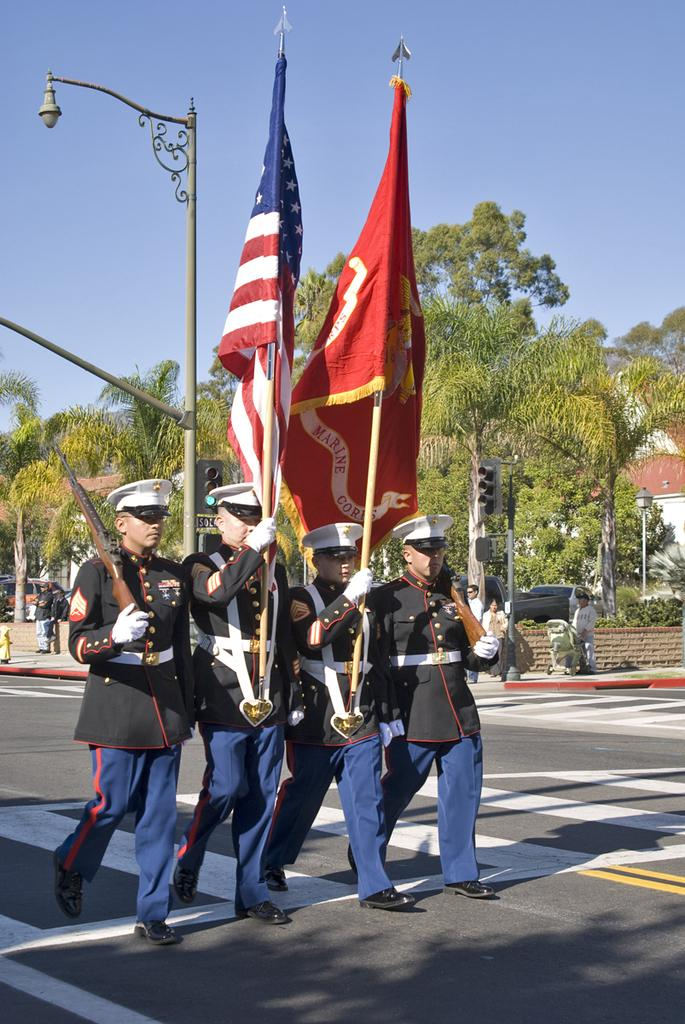How many people are in the image? There is a group of persons in the image. What are the persons in the image doing? The persons are walking in the center of the image and holding flags and guns. What can be seen in the background of the image? There are trees and a pole in the background of the image, as well as additional persons. What type of giants can be seen interacting with the bears in the image? There are no giants or bears present in the image. What is the relation between the persons holding flags and the persons holding guns in the image? The provided facts do not mention any specific relation between the persons holding flags and the persons holding guns; they are simply part of the same group. 